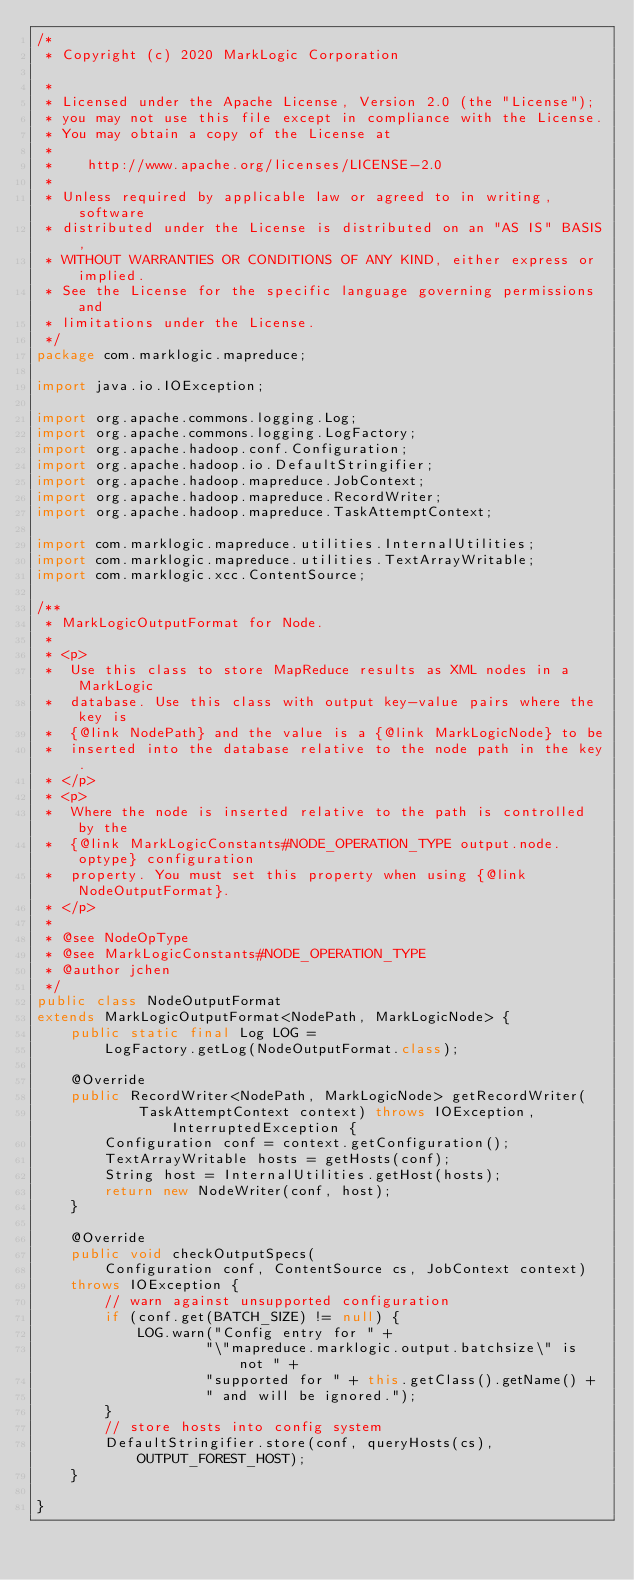<code> <loc_0><loc_0><loc_500><loc_500><_Java_>/*
 * Copyright (c) 2020 MarkLogic Corporation

 *
 * Licensed under the Apache License, Version 2.0 (the "License");
 * you may not use this file except in compliance with the License.
 * You may obtain a copy of the License at
 *
 *    http://www.apache.org/licenses/LICENSE-2.0
 *
 * Unless required by applicable law or agreed to in writing, software
 * distributed under the License is distributed on an "AS IS" BASIS,
 * WITHOUT WARRANTIES OR CONDITIONS OF ANY KIND, either express or implied.
 * See the License for the specific language governing permissions and
 * limitations under the License.
 */
package com.marklogic.mapreduce;

import java.io.IOException;

import org.apache.commons.logging.Log;
import org.apache.commons.logging.LogFactory;
import org.apache.hadoop.conf.Configuration;
import org.apache.hadoop.io.DefaultStringifier;
import org.apache.hadoop.mapreduce.JobContext;
import org.apache.hadoop.mapreduce.RecordWriter;
import org.apache.hadoop.mapreduce.TaskAttemptContext;

import com.marklogic.mapreduce.utilities.InternalUtilities;
import com.marklogic.mapreduce.utilities.TextArrayWritable;
import com.marklogic.xcc.ContentSource;

/**
 * MarkLogicOutputFormat for Node.
 * 
 * <p>
 *  Use this class to store MapReduce results as XML nodes in a MarkLogic
 *  database. Use this class with output key-value pairs where the key is
 *  {@link NodePath} and the value is a {@link MarkLogicNode} to be 
 *  inserted into the database relative to the node path in the key.
 * </p>
 * <p>
 *  Where the node is inserted relative to the path is controlled by the
 *  {@link MarkLogicConstants#NODE_OPERATION_TYPE output.node.optype} configuration
 *  property. You must set this property when using {@link NodeOutputFormat}.
 * </p>
 * 
 * @see NodeOpType
 * @see MarkLogicConstants#NODE_OPERATION_TYPE
 * @author jchen
 */
public class NodeOutputFormat 
extends MarkLogicOutputFormat<NodePath, MarkLogicNode> {
    public static final Log LOG =
        LogFactory.getLog(NodeOutputFormat.class);
    
    @Override
    public RecordWriter<NodePath, MarkLogicNode> getRecordWriter(
            TaskAttemptContext context) throws IOException, InterruptedException {
        Configuration conf = context.getConfiguration();
        TextArrayWritable hosts = getHosts(conf);
        String host = InternalUtilities.getHost(hosts);
        return new NodeWriter(conf, host);
    }

    @Override
    public void checkOutputSpecs(
        Configuration conf, ContentSource cs, JobContext context)
    throws IOException {
        // warn against unsupported configuration
        if (conf.get(BATCH_SIZE) != null) {
            LOG.warn("Config entry for " +
                    "\"mapreduce.marklogic.output.batchsize\" is not " +
                    "supported for " + this.getClass().getName() + 
                    " and will be ignored.");
        }     
        // store hosts into config system
        DefaultStringifier.store(conf, queryHosts(cs), OUTPUT_FOREST_HOST);
    }

}
</code> 